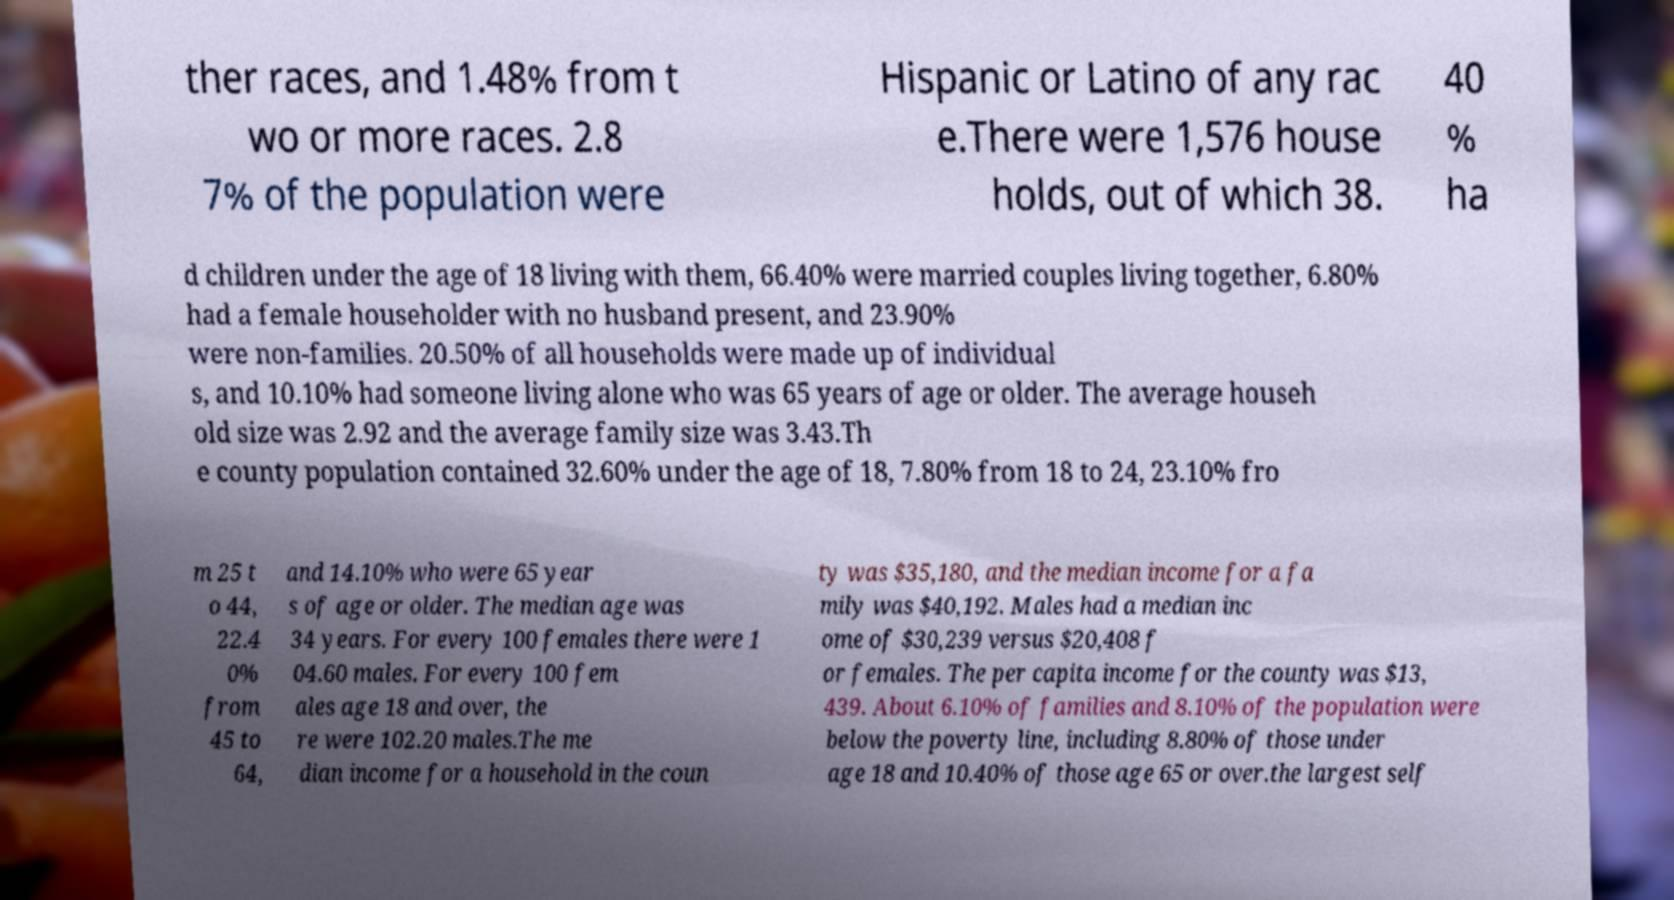For documentation purposes, I need the text within this image transcribed. Could you provide that? ther races, and 1.48% from t wo or more races. 2.8 7% of the population were Hispanic or Latino of any rac e.There were 1,576 house holds, out of which 38. 40 % ha d children under the age of 18 living with them, 66.40% were married couples living together, 6.80% had a female householder with no husband present, and 23.90% were non-families. 20.50% of all households were made up of individual s, and 10.10% had someone living alone who was 65 years of age or older. The average househ old size was 2.92 and the average family size was 3.43.Th e county population contained 32.60% under the age of 18, 7.80% from 18 to 24, 23.10% fro m 25 t o 44, 22.4 0% from 45 to 64, and 14.10% who were 65 year s of age or older. The median age was 34 years. For every 100 females there were 1 04.60 males. For every 100 fem ales age 18 and over, the re were 102.20 males.The me dian income for a household in the coun ty was $35,180, and the median income for a fa mily was $40,192. Males had a median inc ome of $30,239 versus $20,408 f or females. The per capita income for the county was $13, 439. About 6.10% of families and 8.10% of the population were below the poverty line, including 8.80% of those under age 18 and 10.40% of those age 65 or over.the largest self 